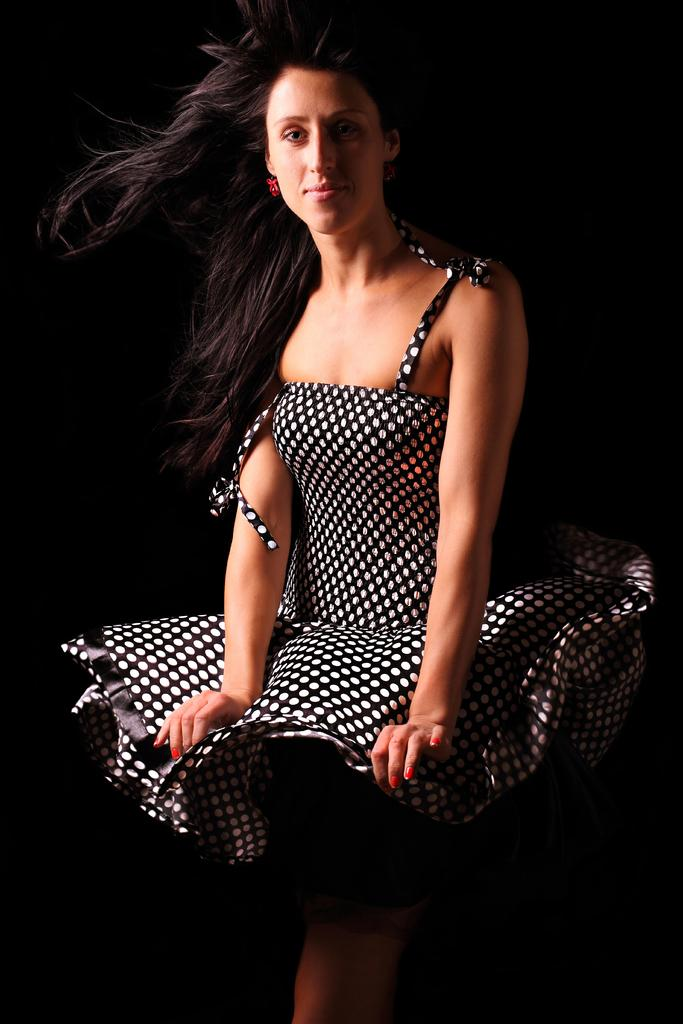What is the main subject of the image? The main subject of the image is a girl. What is the girl doing in the image? The girl is standing in the image. How many passengers are visible in the image? There are no passengers present in the image, as it features a girl standing. What does the girl believe about the existence of unicorns in the image? There is no information about the girl's beliefs in the image. 